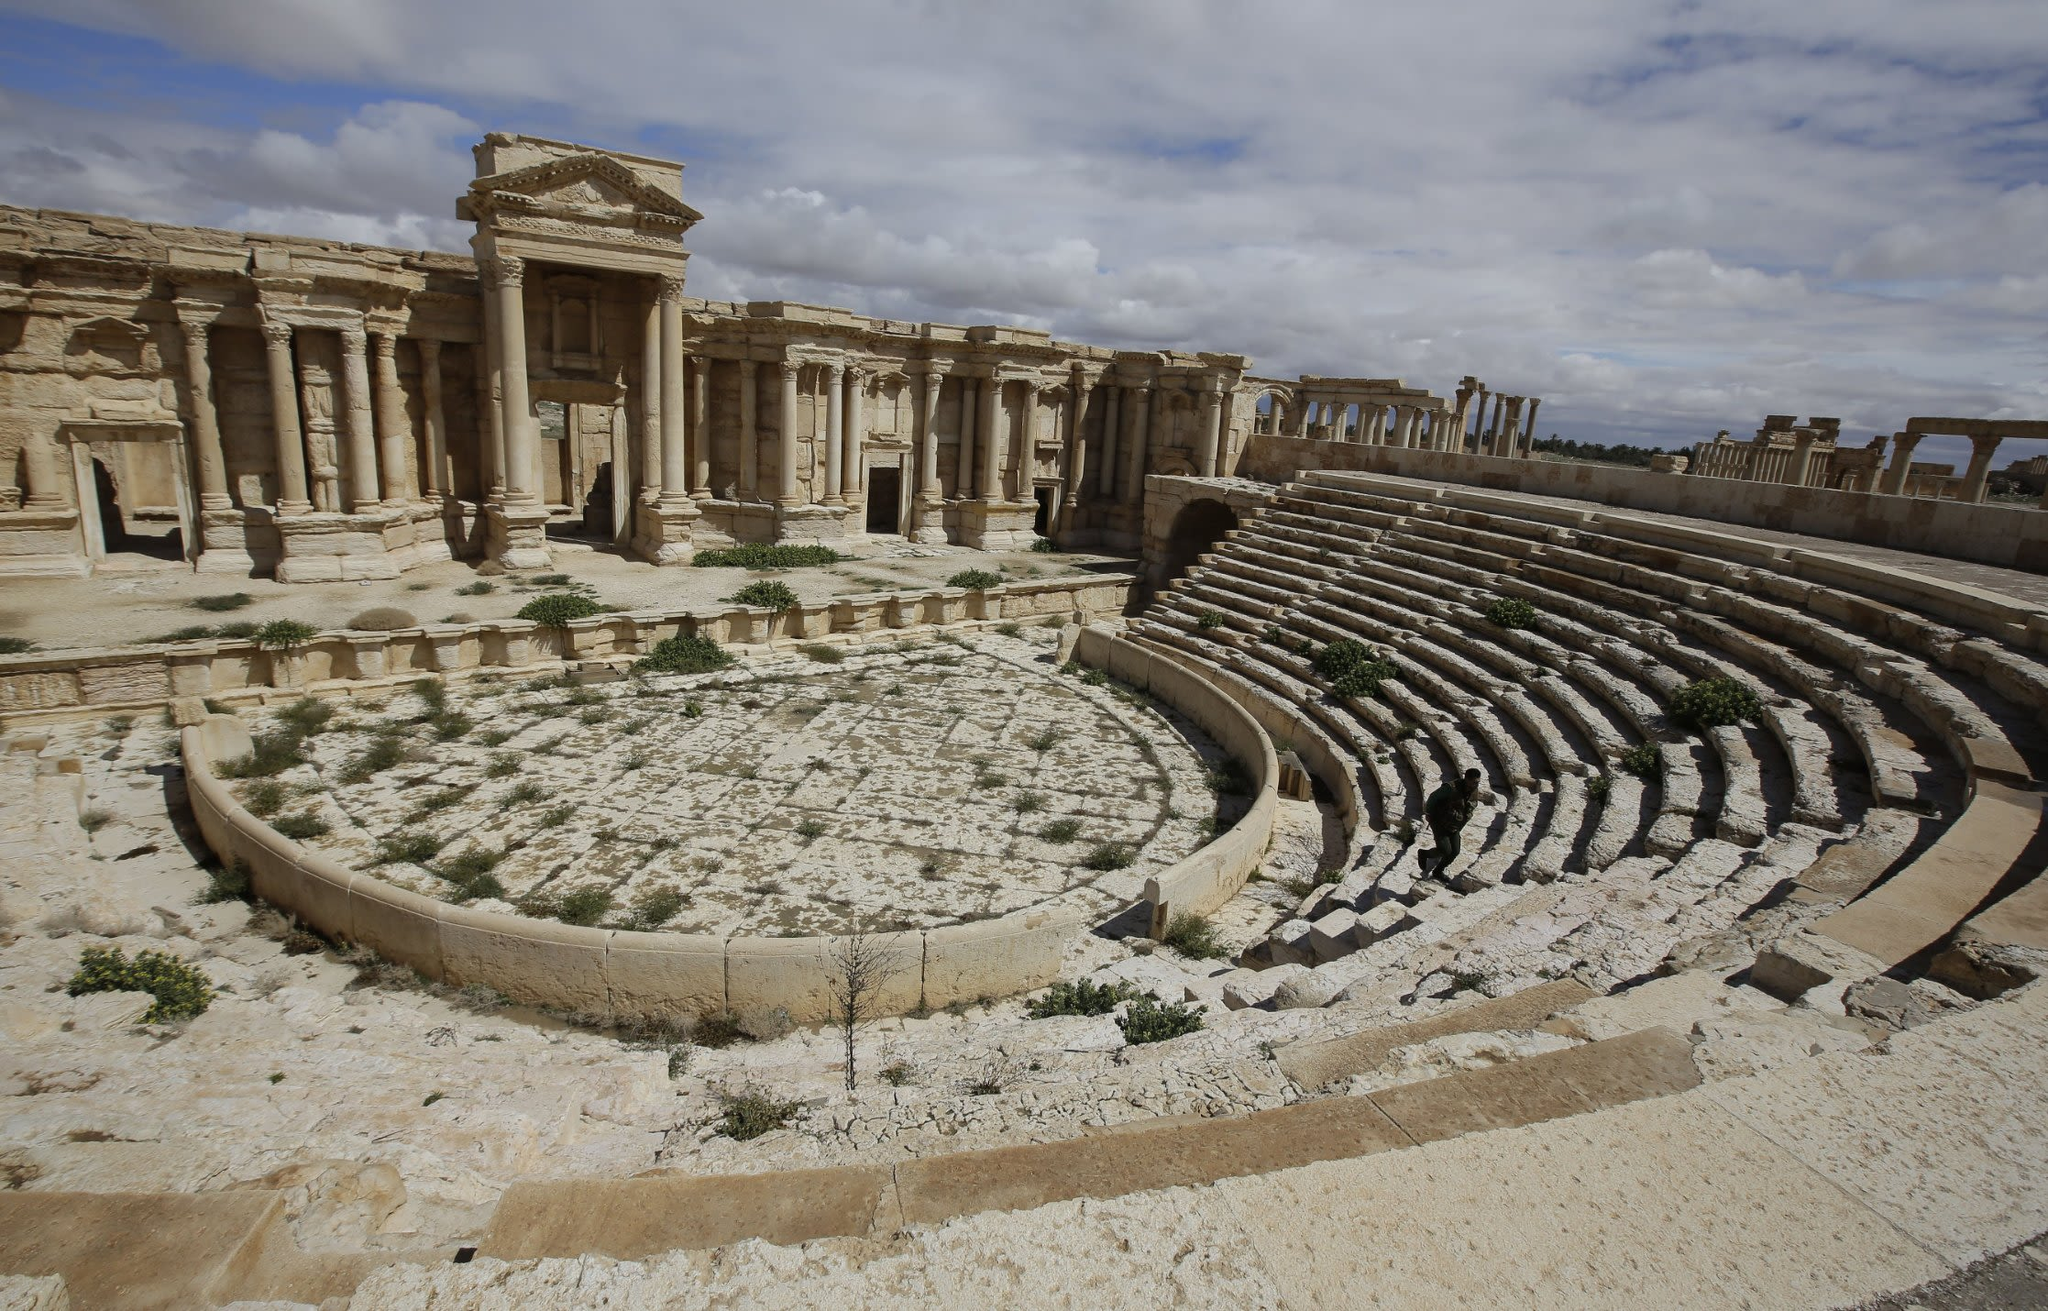Can you explain the historical importance of the architectural design seen here? Certainly! The architectural design of Palmyra's theater reflects Greco-Roman influences, typical of the period. The semicircular orchestra and the cavea (seating area) are designed for optimal acoustics, a hallmark of Roman theaters. This design facilitated not just entertainment but also community gatherings and political discussion, playing a crucial role in the social and public life of Palmyra during its peak. 